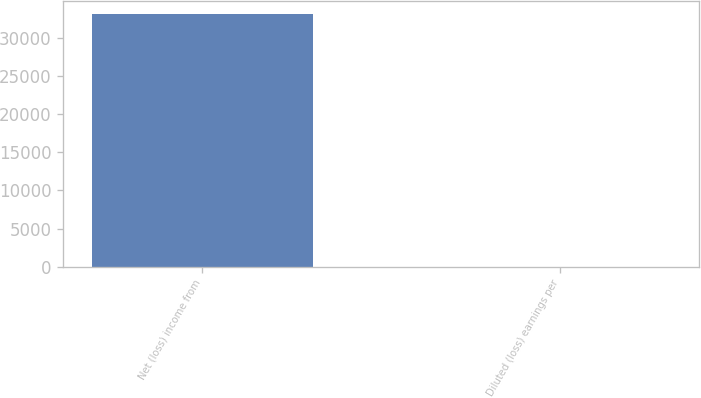Convert chart. <chart><loc_0><loc_0><loc_500><loc_500><bar_chart><fcel>Net (loss) income from<fcel>Diluted (loss) earnings per<nl><fcel>33168<fcel>0.09<nl></chart> 